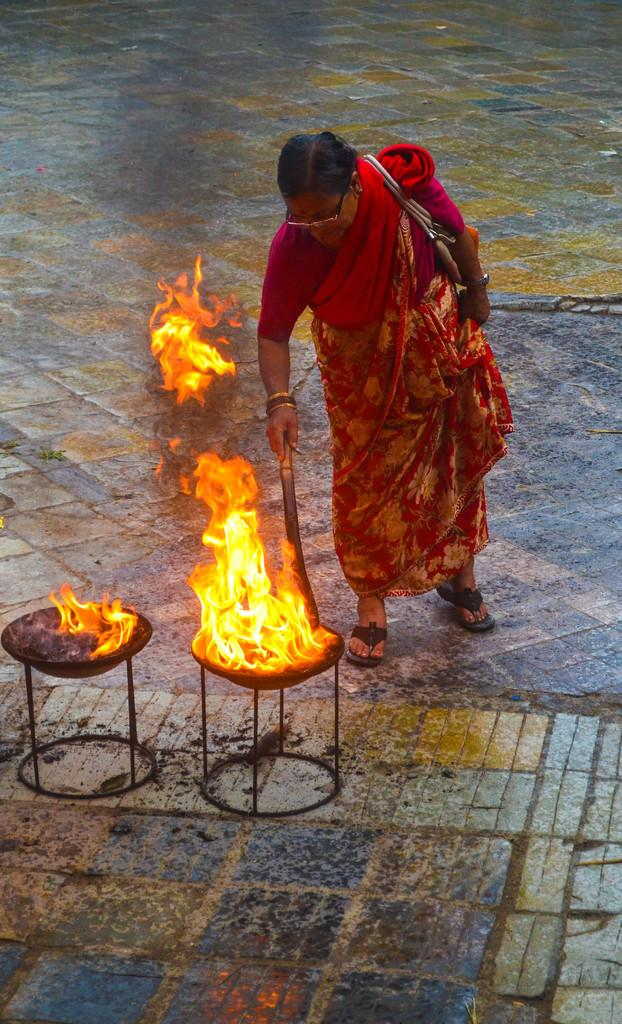What is the main subject of the image? There is a woman in the image. What is the woman doing in the image? The woman is standing in the image. What is the woman holding in the image? The woman is holding an object in the image. What else is the woman carrying in the image? The woman is carrying a bag in the image. What can be seen in the background of the image? There is fire with stands on a surface in the image. How many kittens are playing near the gate in the image? There are no kittens or gates present in the image. What type of wash is the woman performing on the object she is holding? There is no indication of any washing activity in the image, and the object the woman is holding is not specified. 